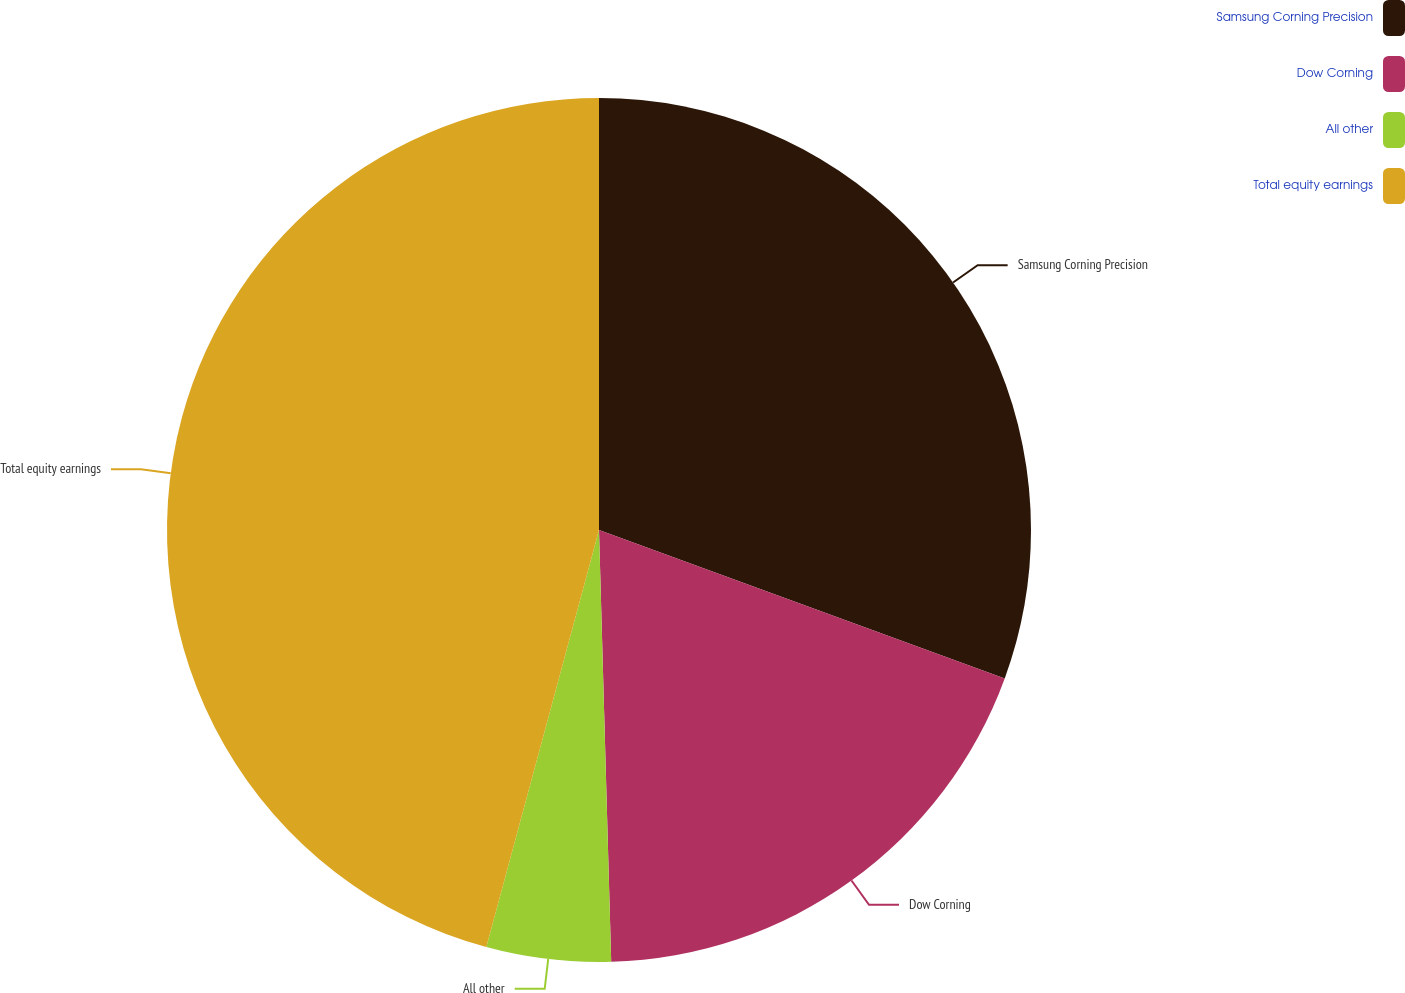Convert chart to OTSL. <chart><loc_0><loc_0><loc_500><loc_500><pie_chart><fcel>Samsung Corning Precision<fcel>Dow Corning<fcel>All other<fcel>Total equity earnings<nl><fcel>30.58%<fcel>18.97%<fcel>4.65%<fcel>45.8%<nl></chart> 